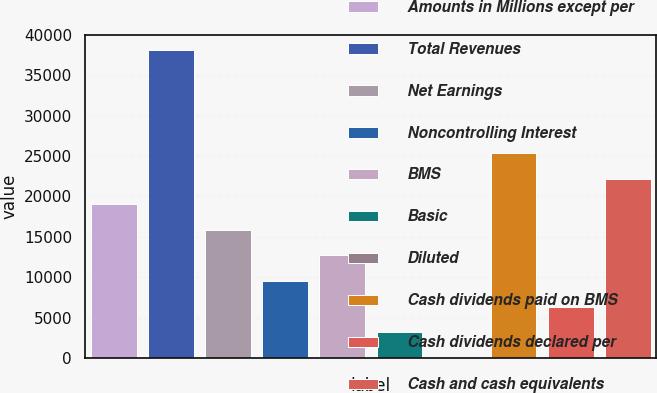Convert chart. <chart><loc_0><loc_0><loc_500><loc_500><bar_chart><fcel>Amounts in Millions except per<fcel>Total Revenues<fcel>Net Earnings<fcel>Noncontrolling Interest<fcel>BMS<fcel>Basic<fcel>Diluted<fcel>Cash dividends paid on BMS<fcel>Cash dividends declared per<fcel>Cash and cash equivalents<nl><fcel>19049.2<fcel>38097.4<fcel>15874.5<fcel>9525.06<fcel>12699.8<fcel>3175.64<fcel>0.93<fcel>25398.6<fcel>6350.35<fcel>22223.9<nl></chart> 